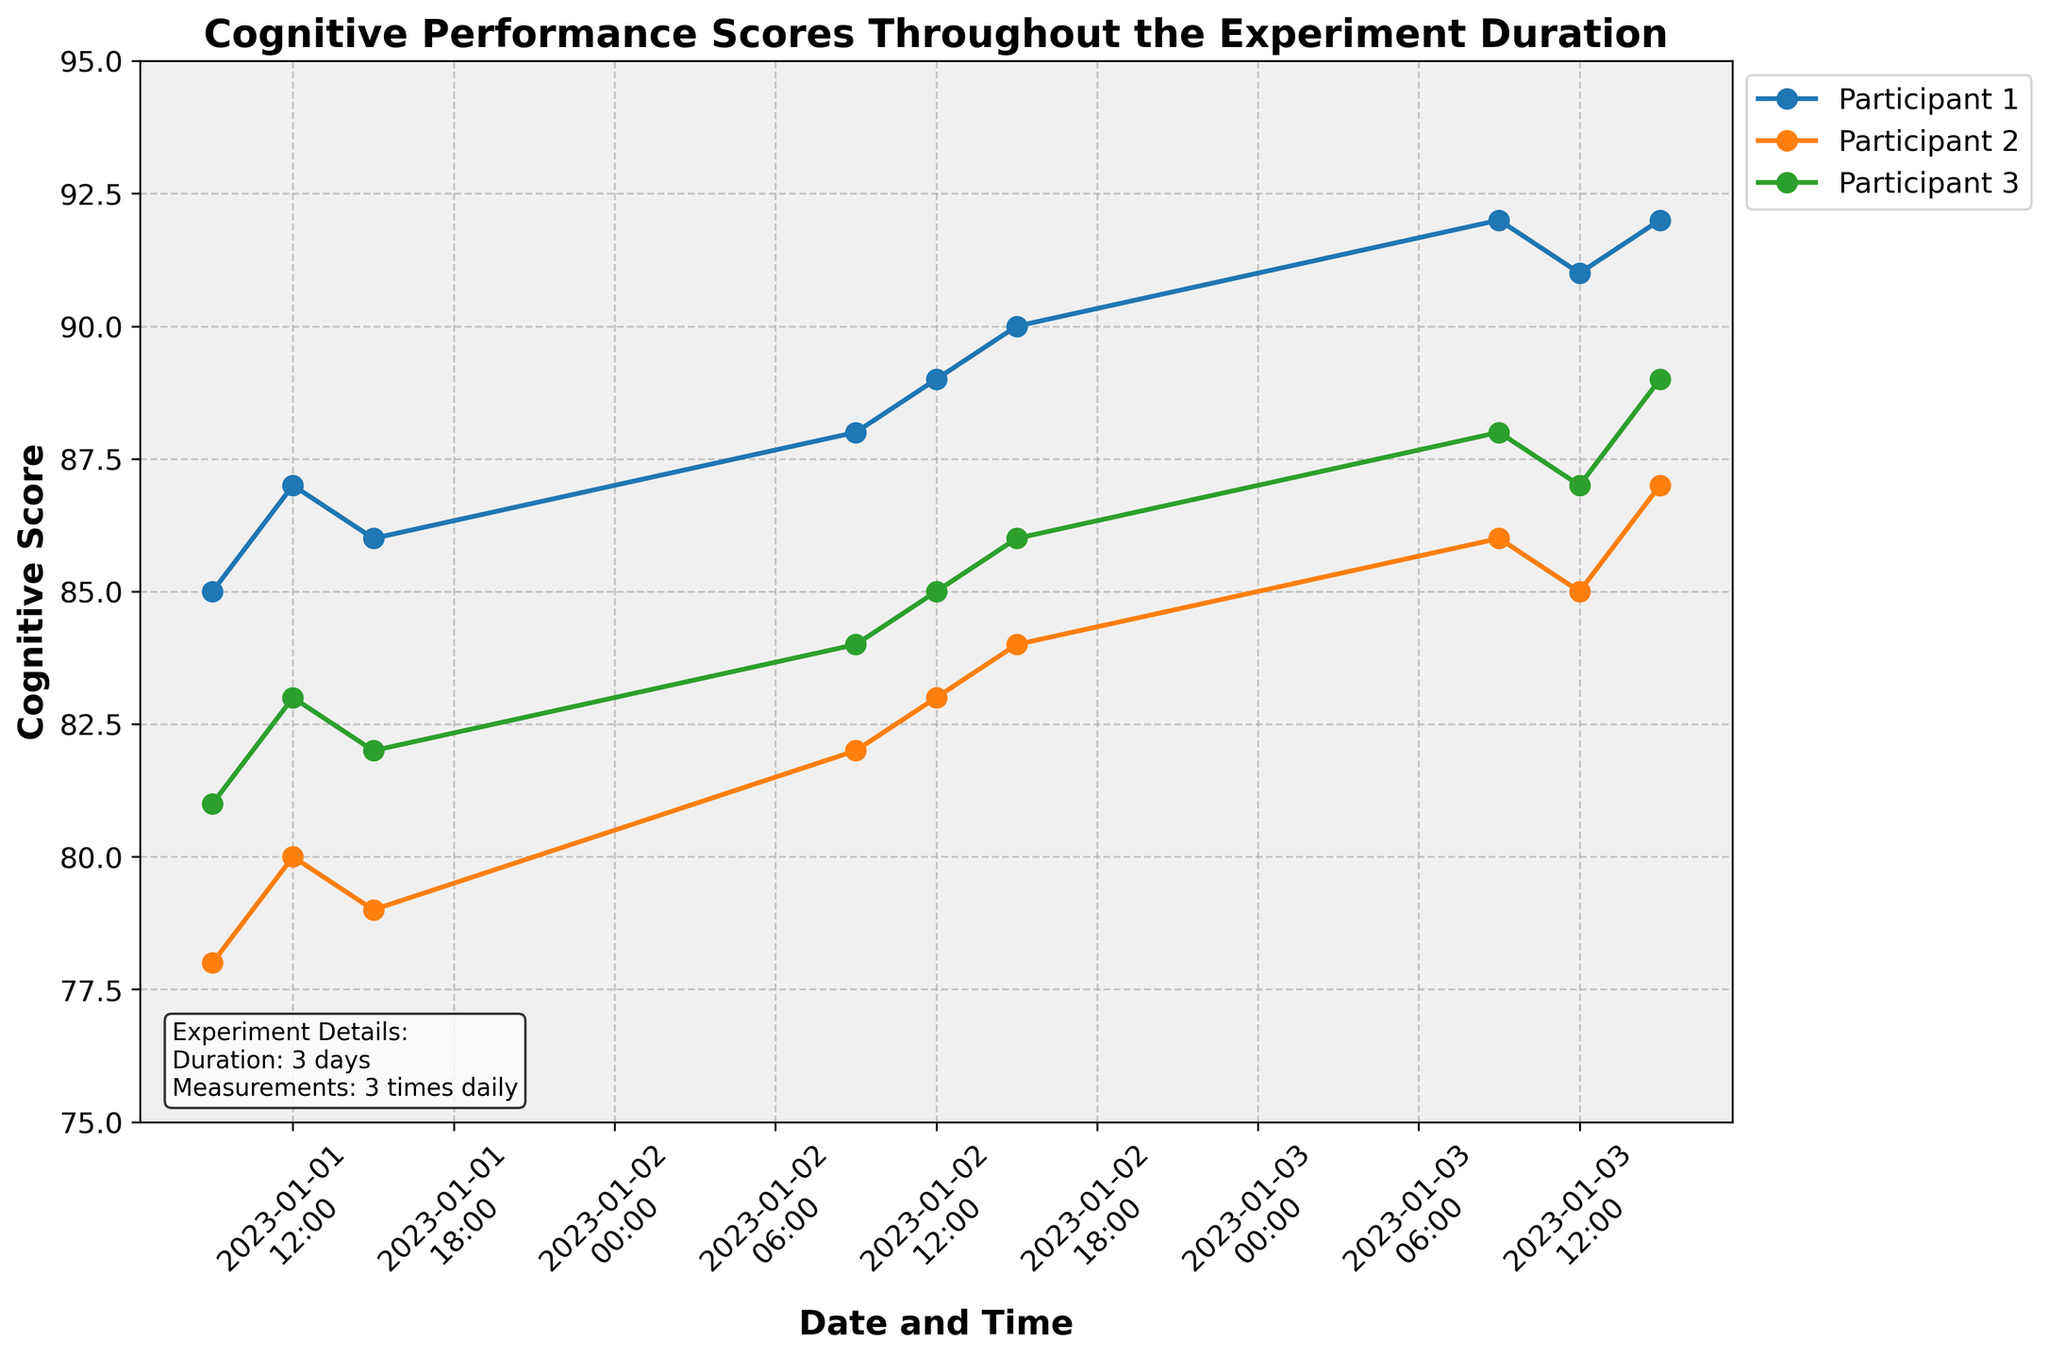What is the title of the plot? The title of the plot is located at the top of the figure. It usually provides a summary of what the plot represents. The title in this case reads: "Cognitive Performance Scores Throughout the Experiment Duration."
Answer: Cognitive Performance Scores Throughout the Experiment Duration How many participants were involved in the experiment? To identify the number of participants, look at the legend on the plot which shows lines labeled for different participants. There are three participants labeled as Participant 001, Participant 002, and Participant 003.
Answer: 3 When were the cognitive scores recorded each day? Examining the x-axis labels, which show dates and times, it can be observed that scores were recorded at three times each day: 09:00 AM, 12:00 PM, and 15:00 PM.
Answer: 09:00, 12:00, 15:00 What is the highest cognitive score recorded and which participant achieved it? The highest cognitive score can be found by observing the y-axis values and the markers on the plot. The maximum score recorded is 92, achieved by Participant 001 and Participant 003.
Answer: 92, Participant 001 and 003 Which participant showed the largest increase in cognitive score over the experiment duration? To determine the largest increase, we calculate the difference between the first and the last cognitive scores for each participant. Participant 001: 92-85 = 7, Participant 002: 87-78 = 9, Participant 003: 89-81 = 8. Participant 002 showed the largest increase of 9 points.
Answer: Participant 002 On the second day, which participant had the highest cognitive score? By focusing on the data recorded on the second day from the time points 09:00, 12:00, and 15:00, we compare the scores of all participants. Participant 001 had the highest score of 90 at 15:00.
Answer: Participant 001 What is the overall trend of cognitive performance for Participant 001 throughout the experiment? Observing the line for Participant 001 across the various timestamps, it is clear that the cognitive performance generally increased over time with some fluctuations, eventually reaching a peak score of 92.
Answer: Increasing trend Compare the cognitive scores of all participants at 12:00 on the first and third day. For the first day at 12:00, Participant 001: 87, Participant 002: 80, Participant 003: 83. For the third day at 12:00, Participant 001: 91, Participant 002: 85, Participant 003: 87. By comparison, all participants showed an increase in their scores on the third day at 12:00 compared to the first day.
Answer: All participants showed an increase What general pattern can be observed for Participant 003's cognitive score over the three days? Looking at Participant 003's scores across three days, the cognitive score shows a gradual increase each day: from 81 to 89. This indicates a consistent improvement in cognitive performance over the experiment duration.
Answer: Gradual increase 